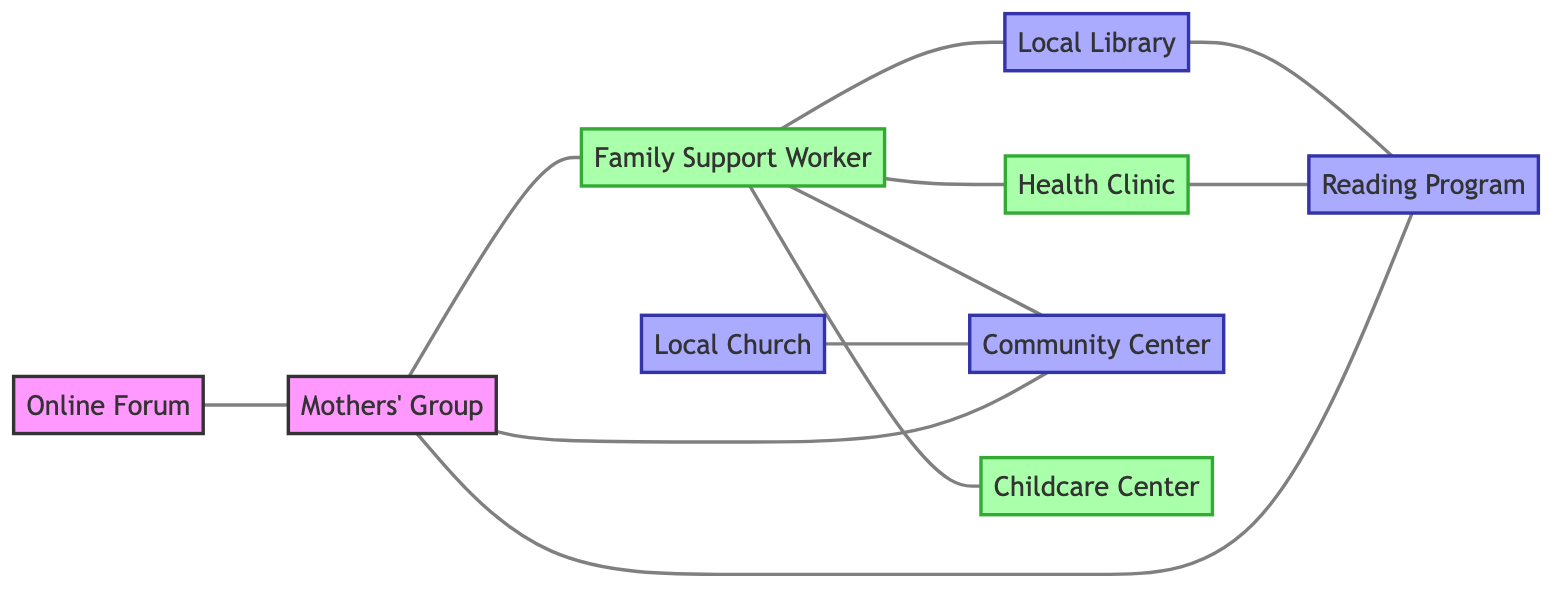What is the total number of nodes in the diagram? By counting all unique entities included in the data under "nodes" we see there are 9 unique nodes: Mothers' Group, Family Support Worker, Local Library, Health Clinic, Community Center, Reading Program, Childcare Center, Local Church, and Online Forum. Therefore, the total is 9.
Answer: 9 Which node is directly connected to the Childcare Center? Looking at the "links" data, the only connection listed is from Family Support Worker to Childcare Center. This indicates that only the Family Support Worker is directly connected to the Childcare Center.
Answer: Family Support Worker How many resources are listed in the diagram? The "resource" class includes Local Library, Community Center, Reading Program, and Local Church. Counting these gives a total of 4 resources present in the diagram.
Answer: 4 Who is linked to the Local Library? According to the connections in the "links" section, the Family Support Worker and Reading Program are the nodes that are connected to Local Library. However, since the question asks for a specific link, the main direct connection from this perspective is Family Support Worker.
Answer: Family Support Worker Which node represents the online support platform for mothers? The node labeled "Online Forum" is specified in the diagram as the support platform designed for mothers to connect and share resources.
Answer: Online Forum Is there a direct connection between Mothers' Group and Health Clinic? Checking the links, there is no direct link specified between Mothers' Group and Health Clinic, as the only connection to Health Clinic is through Family Support Worker. Thus, there is no direct connection.
Answer: No Which two nodes are connected through community resources? The nodes Local Church and Community Center are connected, representing a community resource sharing relationship. Thus, these two nodes specifically exemplify the connection through resources.
Answer: Local Church, Community Center How many unique edges are present in the diagram? The "links" data provides a list of all edges in the diagram: 10 unique connections (from the pairs defined in the "links" section), indicating a total of 10 edges.
Answer: 10 What type of support does the Family Support Worker provide? The Family Support Worker is categorized as a support node in the diagram and is connected to several other key community resources that assist mothers, indicating its supportive role.
Answer: Support 